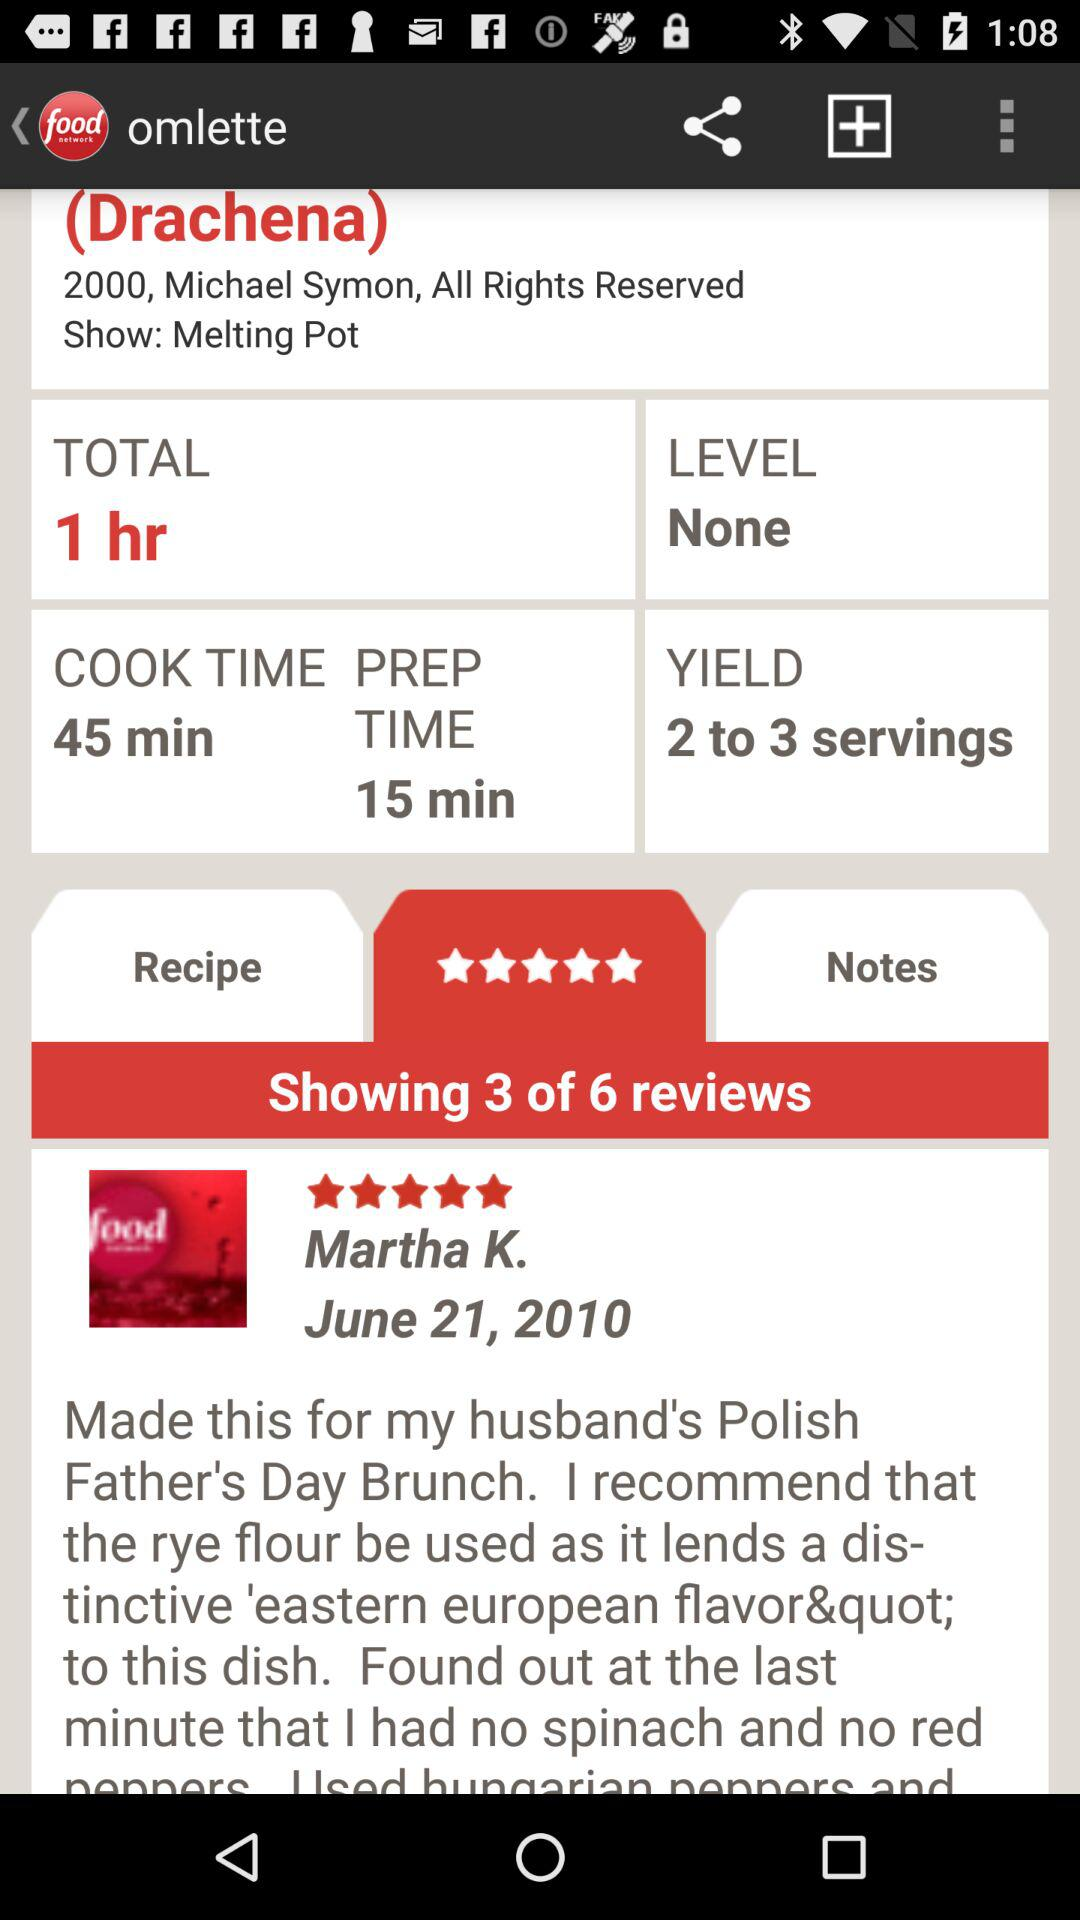What is the prep time? The prep time is 15 minutes. 